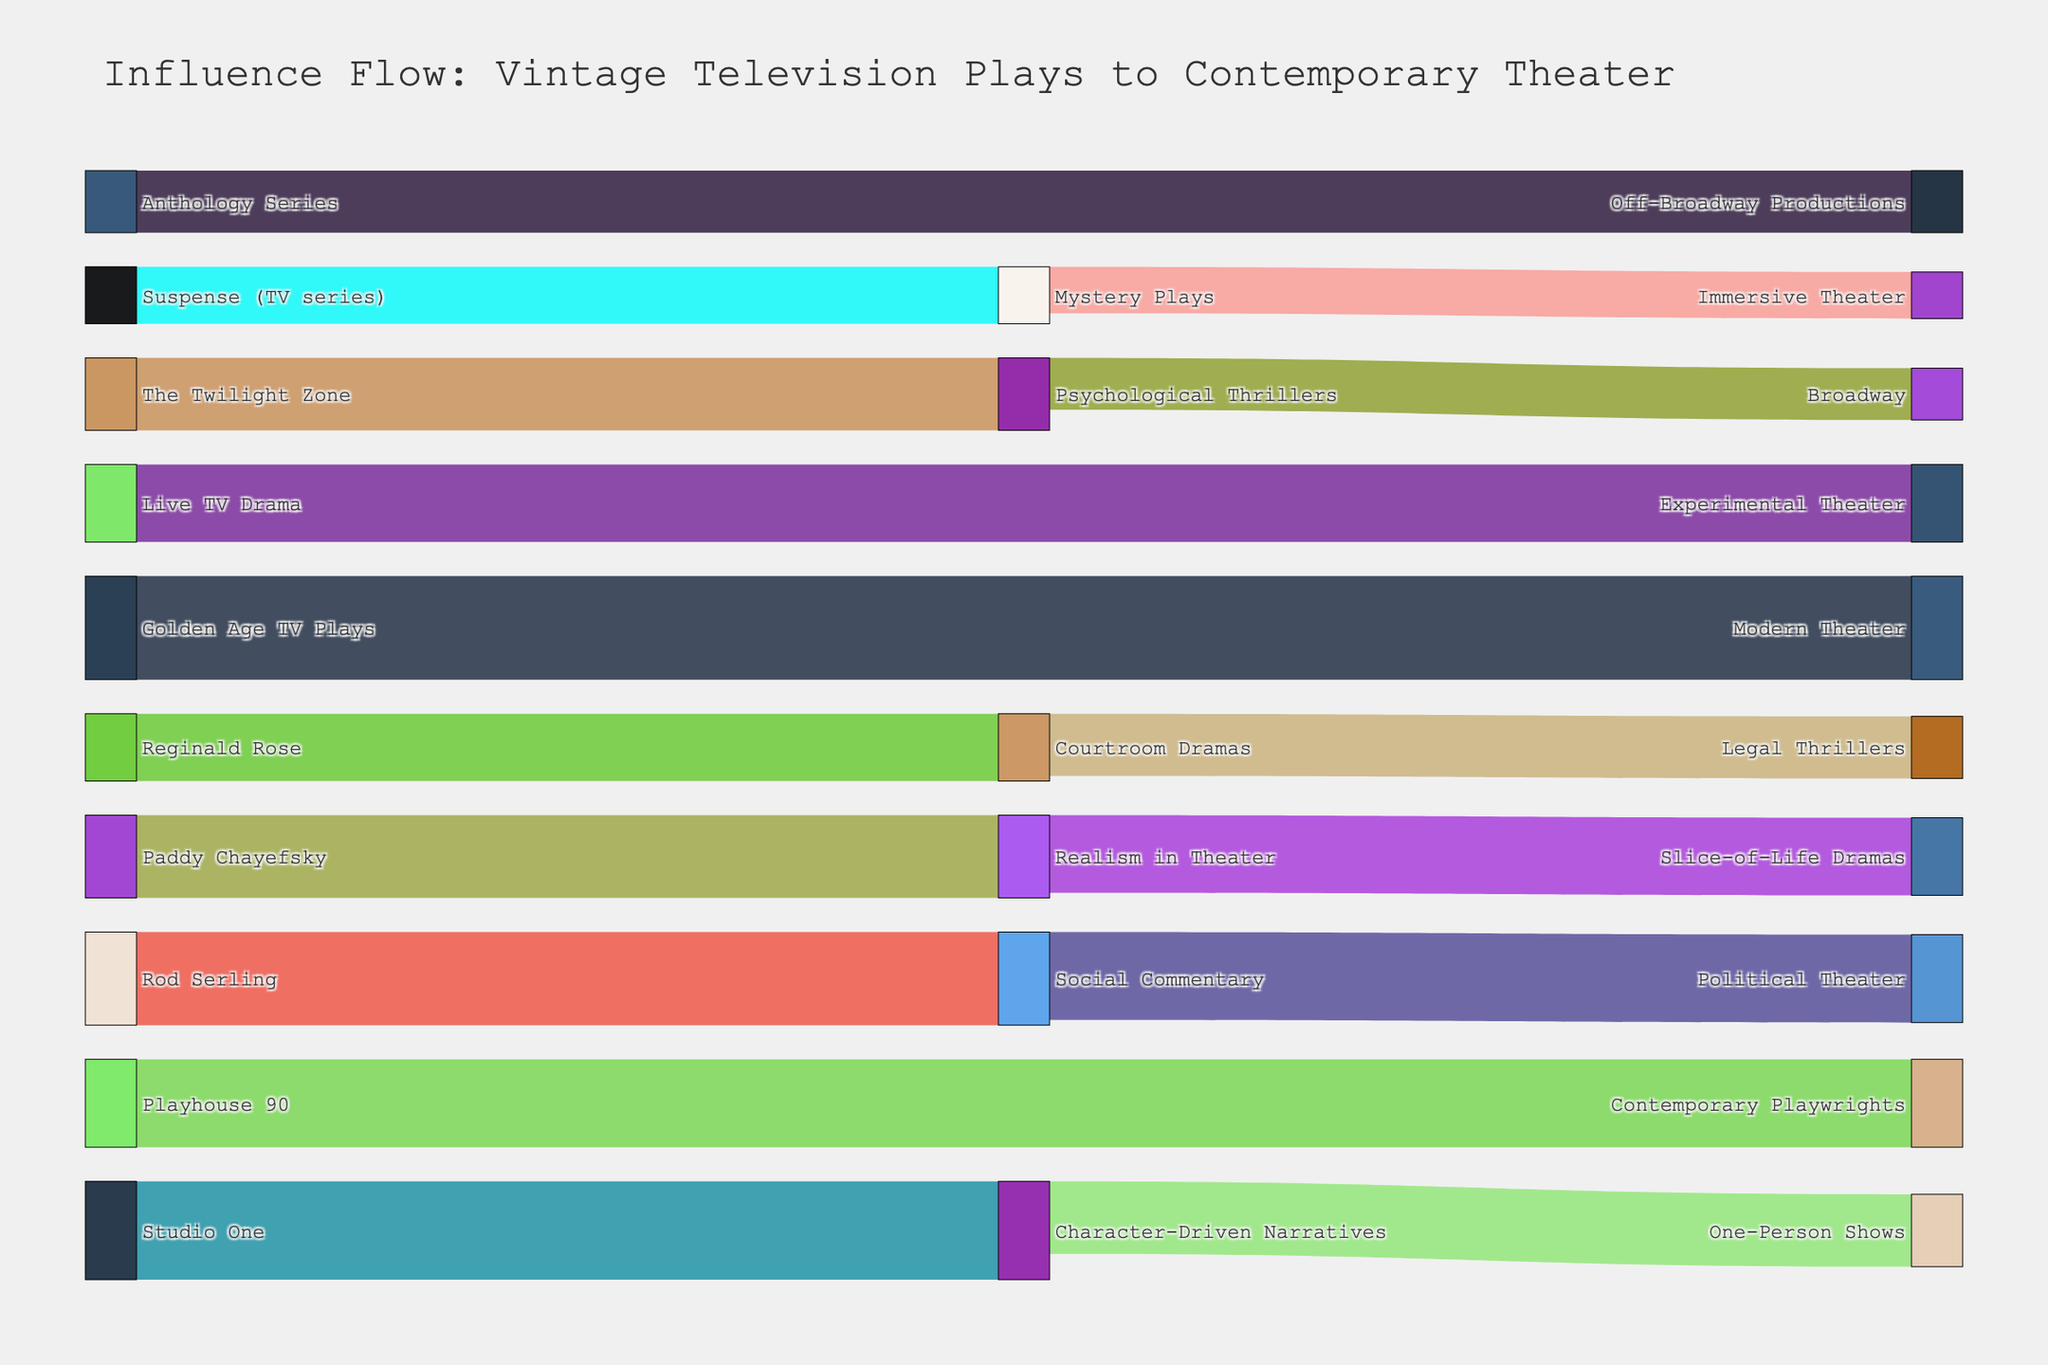what is the title of the figure? The title of the figure is usually prominently displayed at the top. In this case, it states the purpose of the figure.
Answer: Influence Flow: Vintage Television Plays to Contemporary Theater Which vintage television play has the highest influence on contemporary theater? By examining the width of the flows from each vintage TV play, we can deduce which one has the highest influence. The flow from "Golden Age TV Plays" to "Modern Theater" has the widest band, indicating the highest influence.
Answer: Golden Age TV Plays What's the combined influence of "Rod Serling" and "Paddy Chayefsky" on contemporary theater? Add the values associated with the flows from both sources. Rod Serling to Social Commentary has a value of 90, and Paddy Chayefsky to Realism in Theater has a value of 80, summing to 170.
Answer: 170 Which flow has a greater influence: "Live TV Drama" to "Experimental Theater" or "Playhouse 90" to "Contemporary Playwrights"? Compare the values of the flows. Live TV Drama to Experimental Theater has a value of 75, while Playhouse 90 to Contemporary Playwrights has a value of 85. The latter is greater.
Answer: Playhouse 90 to Contemporary Playwrights What themes in contemporary theater are influenced by "The Twilight Zone"? Look at the target connected to "The Twilight Zone." There is one direct connection from "The Twilight Zone" to "Psychological Thrillers."
Answer: Psychological Thrillers How does the influence of "Social Commentary" compare to "Mystery Plays" in contemporary theater? Compare the summed values flowing into contemporary themes. Social Commentary flows into Political Theater with a value of 85, and Mystery Plays flows into Immersive Theater with a value of 45. Social Commentary has a greater influence.
Answer: Social Commentary What is the total influence of "Character-Driven Narratives" in contemporary theater? Combine the values connected to Character-Driven Narratives. It flows into One-Person Shows with a value of 70 and originates from Studio One with 95. Calculate 70 + 95 = 165.
Answer: 165 Which narrative technique is most influenced by vintage television plays? Determine from the figure which narrative technique has the highest combined influence from multiple sources. The highest influence value originates from "Character-Driven Narratives" with a sum of 95 (from Studio One).
Answer: Character-Driven Narratives What is the connection between "Realism in Theater" and "Slice-of-Life Dramas"? Trace the path from Realism in Theater to Slice-of-Life Dramas. Realism in Theater directly flows into Slice-of-Life Dramas, showing a direct influence.
Answer: Direct influence 